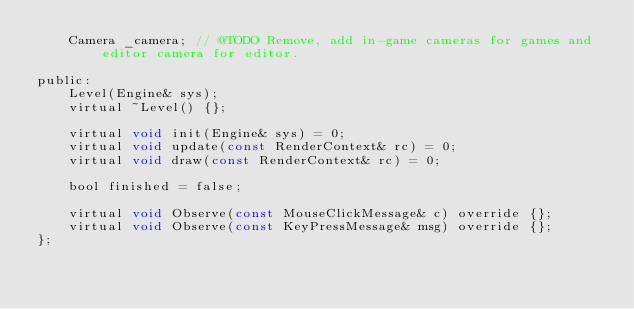<code> <loc_0><loc_0><loc_500><loc_500><_C_>	Camera _camera;	// @TODO Remove, add in-game cameras for games and editor camera for editor.

public:
	Level(Engine& sys);
	virtual ~Level() {};

	virtual void init(Engine& sys) = 0;
	virtual void update(const RenderContext& rc) = 0;
	virtual void draw(const RenderContext& rc) = 0;

	bool finished = false;

	virtual void Observe(const MouseClickMessage& c) override {};
	virtual void Observe(const KeyPressMessage& msg) override {};
};</code> 